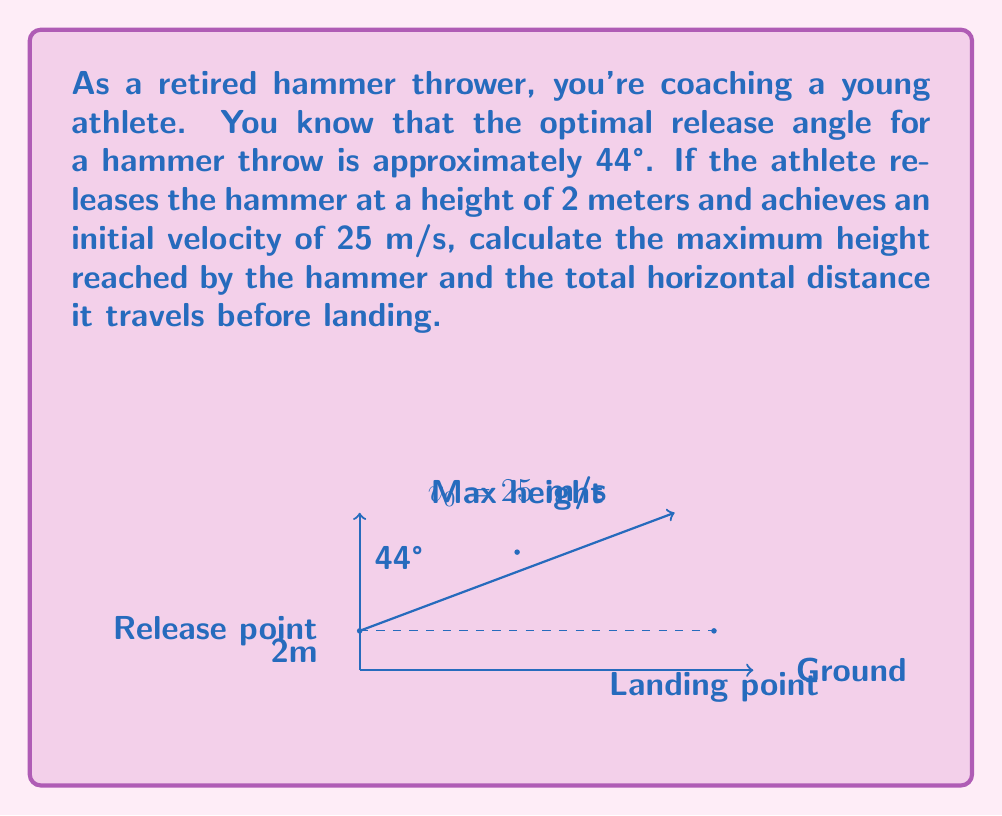Provide a solution to this math problem. Let's approach this problem step-by-step using projectile motion equations and trigonometry:

1) First, let's break down the initial velocity into its horizontal and vertical components:
   $v_{0x} = v_0 \cos \theta = 25 \cos 44° \approx 17.97 \text{ m/s}$
   $v_{0y} = v_0 \sin \theta = 25 \sin 44° \approx 17.36 \text{ m/s}$

2) To find the maximum height, we use the equation:
   $h_{max} = h_0 + \frac{v_{0y}^2}{2g}$
   Where $h_0$ is the initial height (2m) and $g$ is the acceleration due to gravity (9.8 m/s²)
   
   $h_{max} = 2 + \frac{17.36^2}{2(9.8)} \approx 17.36 \text{ m}$

3) The time to reach maximum height is:
   $t_{up} = \frac{v_{0y}}{g} = \frac{17.36}{9.8} \approx 1.77 \text{ s}$

4) The total time of flight is twice this (assuming symmetric flight path):
   $t_{total} = 2t_{up} \approx 3.54 \text{ s}$

5) The horizontal distance traveled is:
   $d = v_{0x} \cdot t_{total} = 17.97 \cdot 3.54 \approx 63.61 \text{ m}$

Therefore, the hammer reaches a maximum height of approximately 17.36 meters and travels a horizontal distance of about 63.61 meters.
Answer: Maximum height: 17.36 m; Horizontal distance: 63.61 m 